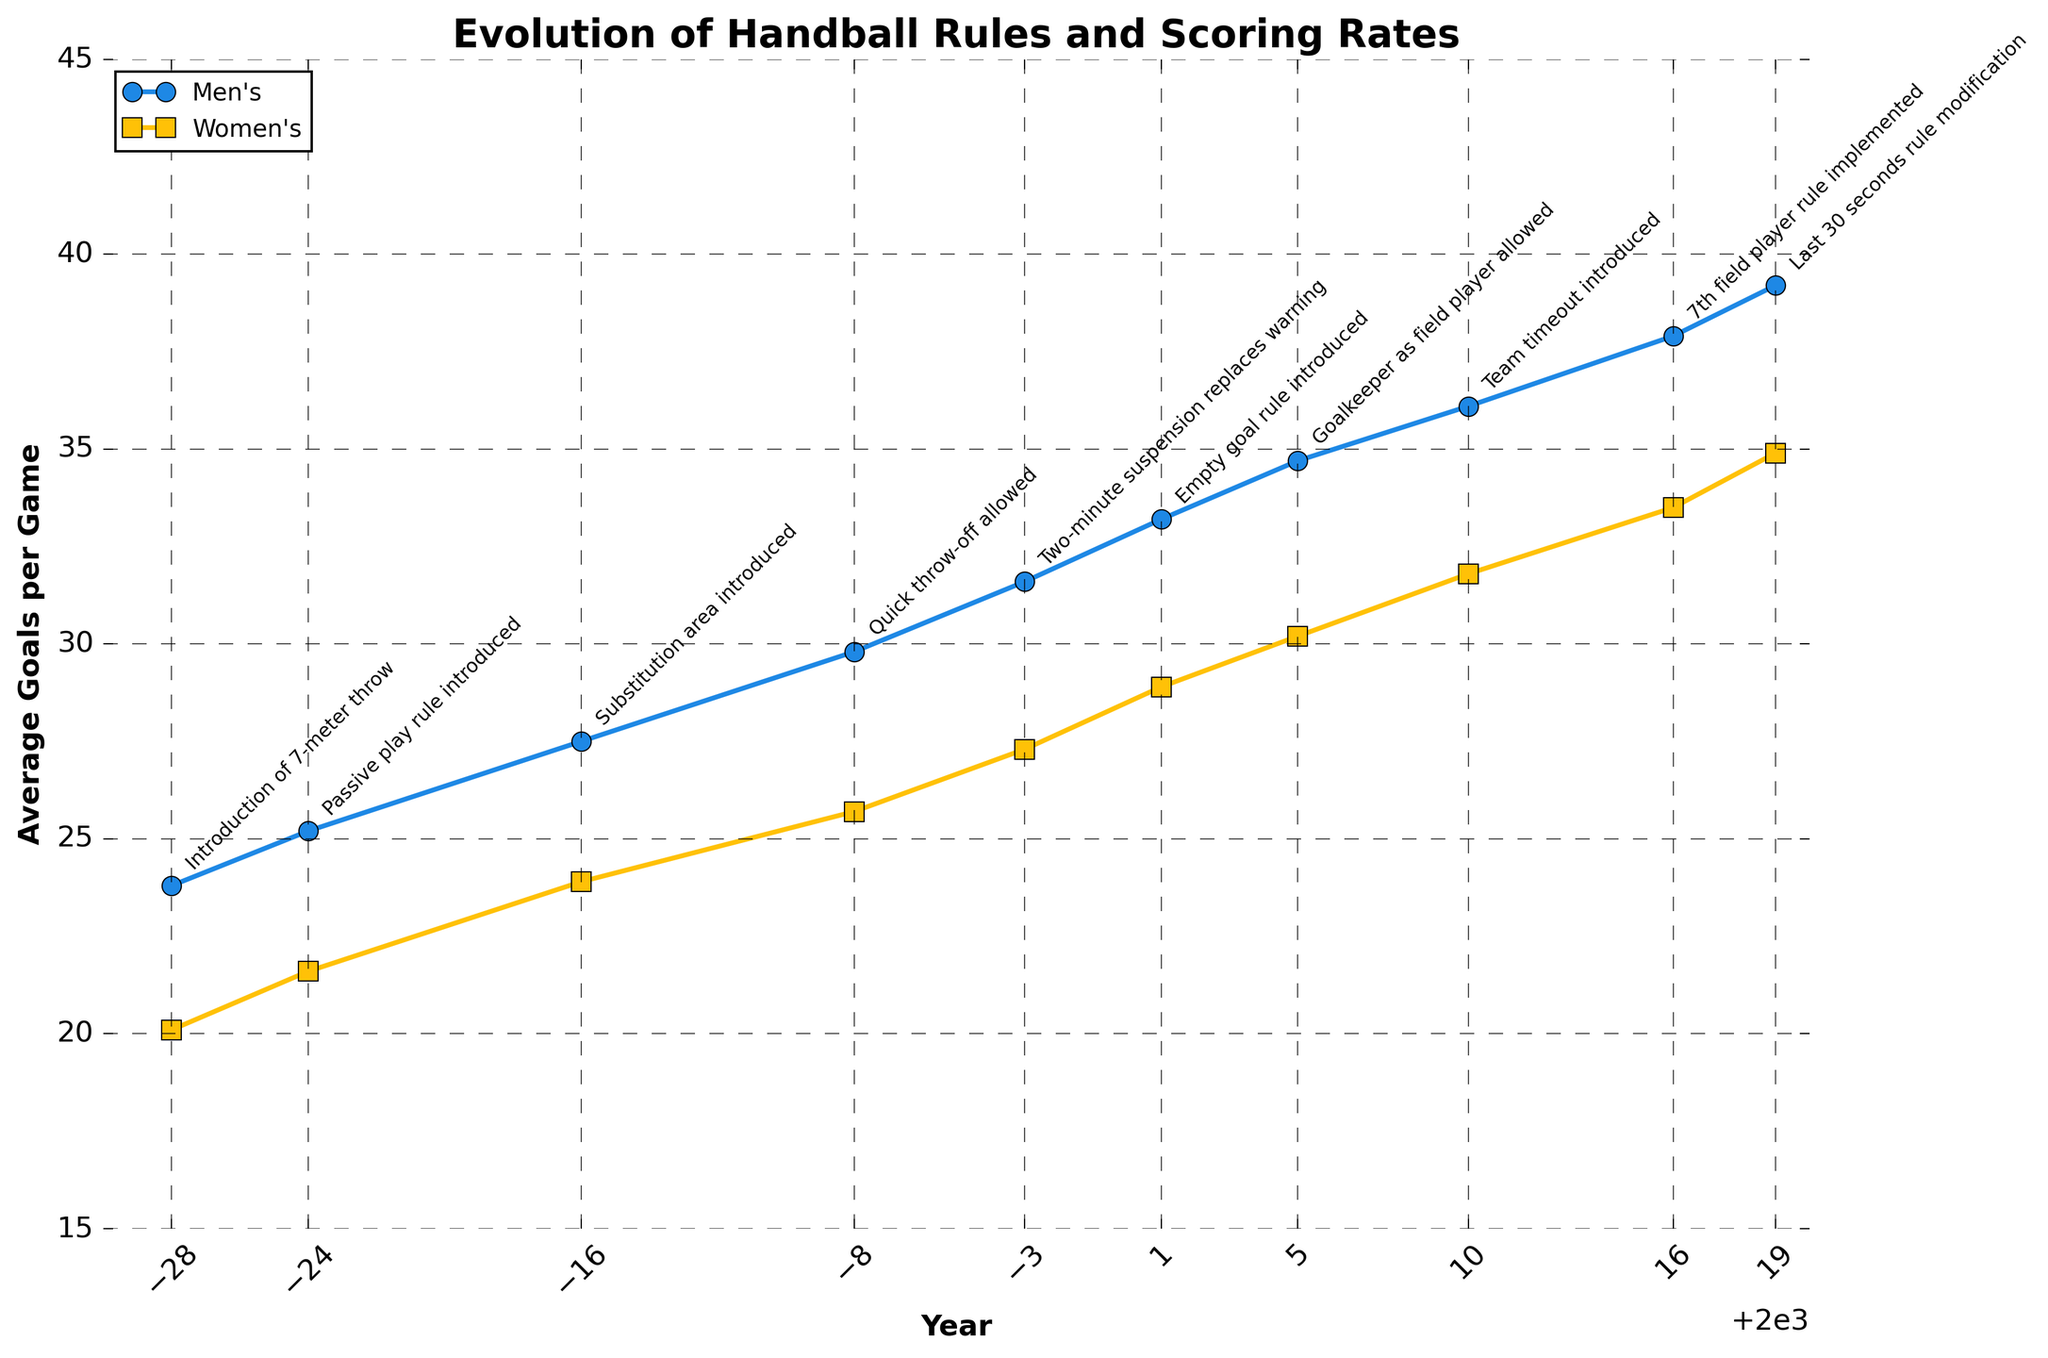What year was the 7-meter throw introduced? The year corresponding to the introduction of the 7-meter throw is given in the dataset.
Answer: 1972 How did the introduction of the 'Two-minute suspension' rule in 1997 impact the average goals per game for men and women? From the dataset, observe the average goals per game for men and women before and after the introduction of this rule. Before 1997, the average for men was 29.8, and for women was 25.7. After 1997, it increased to 31.6 (men) and 27.3 (women).
Answer: Increased Comparing 1972 and 2019, by how many goals did the average goals per game for women's handball increase? Subtract the average goals per game for women in 1972 from that in 2019. 34.9 (2019) - 20.1 (1972) = 14.8
Answer: 14.8 Which year had the highest average goals per game for men's handball, and what was the value? Identify the year with the highest value in the men's average goals per game column.
Answer: 2019, 39.2 At what rate did the average goals per game increase for men from 1984 to 2001? Calculate the difference in goals per game between 1984 and 2001 and then divide by the number of years between them. (33.2 - 27.5) / (2001 - 1984) = 5.7 / 17 ≈ 0.34
Answer: ~0.34 goals per year What was the average increase in goals per game for women's handball after the introduction of the 'Empty goal' rule in 2001? Compare the average goals per game for women before and after 2001. The value before 2001 is 27.3, and after 2001 is 28.9. The increase is 28.9 - 27.3 = 1.6
Answer: 1.6 Which rule change is annotated at the data point with the lowest average goals per game for women's handball? Identify the data point with the lowest value for women's handball and check the associated rule change annotation. The lowest value is 20.1 in 1972, corresponding to the introduction of the 7-meter throw.
Answer: Introduction of 7-meter throw By how many goals did the average goals per game for men's and women's handball differ in 2016? Subtract the average goals per game for women from that for men in 2016. 37.9 (men) - 33.5 (women) = 4.4
Answer: 4.4 Analyze the trend in average goals per game for men’s handball from the introduction of the 'Substitution area' in 1984 to the 'Last 30 seconds' rule modification in 2019. Observe the plotted line for men’s handball from 1984 to 2019. The trend shows a continuous increase in the average goals per game over these years.
Answer: Increasing trend Which rule change is located in the middle of the x-axis range of the plot? The x-axis range is from 1972 to 2019. The mid-point approximately lies around the year 1996. Identify the rule change near this year, which is the introduction of the 'Two-minute suspension' rule in 1997.
Answer: Two-minute suspension replaces warning in 1997 